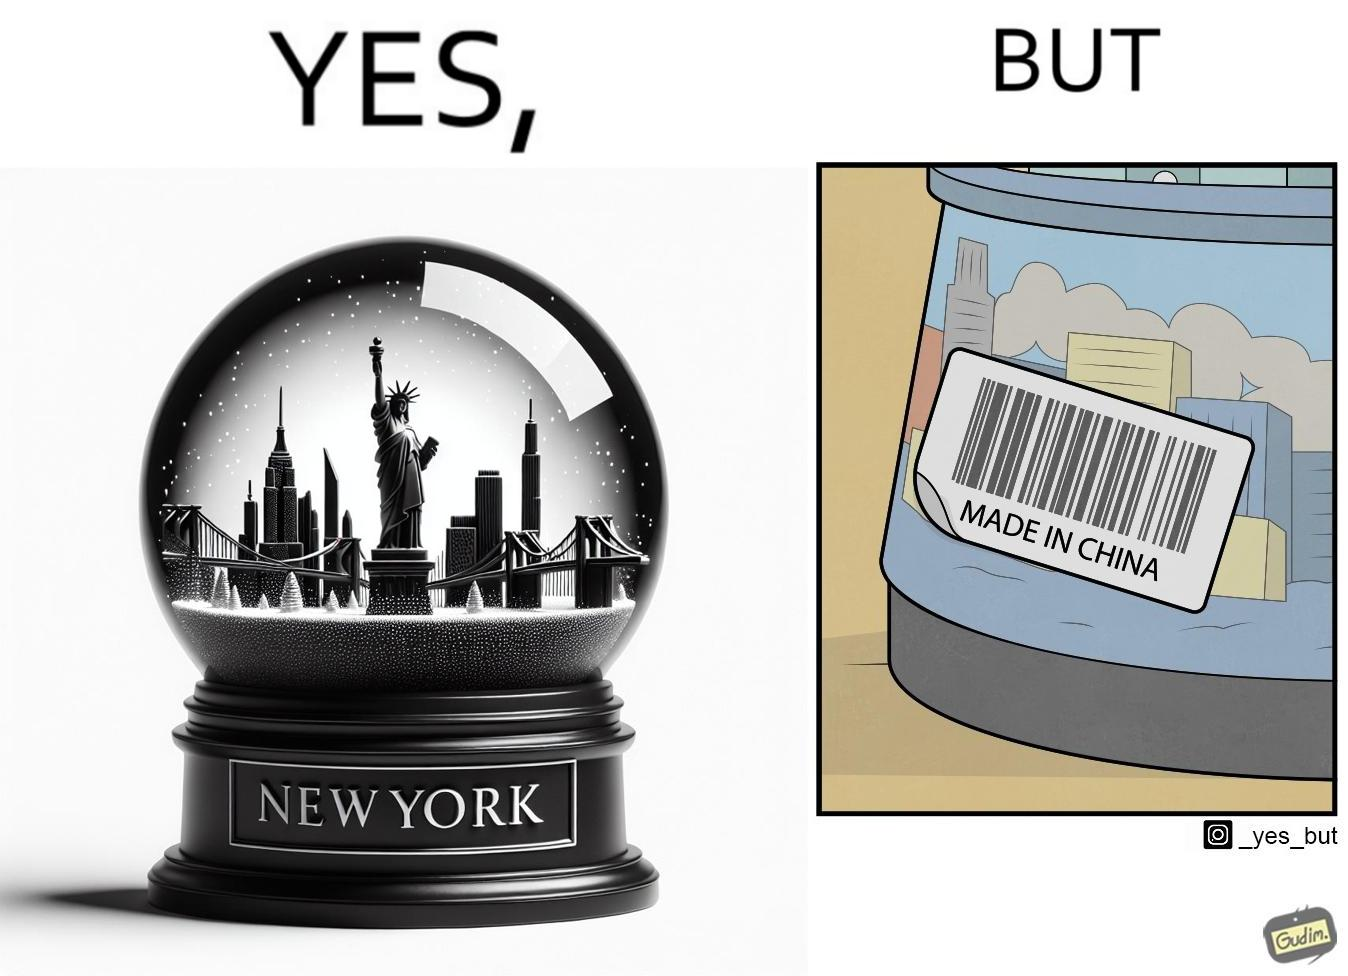Compare the left and right sides of this image. In the left part of the image: A snowglobe that says 'New York' In the right part of the image: Made in china' label on the snowglobe 